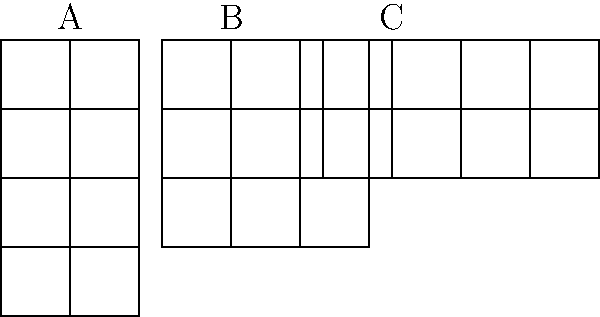Which dashboard layout (A, B, or C) would be most effective for displaying 8 different data quality metrics, considering the need for clear visualization and easy comparison? To determine the most effective layout for displaying 8 data quality metrics, we need to consider several factors:

1. Number of metrics: We need to display 8 metrics.

2. Layout options:
   A: 2 columns x 4 rows = 8 spaces
   B: 3 columns x 3 rows = 9 spaces
   C: 4 columns x 2 rows = 8 spaces

3. Comparison ease: 
   - Layout A allows easy vertical comparison within columns but harder horizontal comparison.
   - Layout B provides a balanced view but has an extra unused space.
   - Layout C offers the best horizontal comparison and maintains symmetry.

4. Screen real estate usage:
   - Layout C makes the most efficient use of horizontal space, which is typically more abundant on modern widescreen displays.

5. Data visualization principles:
   - Layout C adheres to the principle of proximity, grouping related metrics closer together horizontally.
   - It also follows the principle of alignment, creating a clean, organized appearance.

6. Cognitive load:
   - Layout C reduces eye movement by presenting metrics in a more compact horizontal arrangement.

Given these considerations, Layout C (4 columns x 2 rows) is the most effective for displaying 8 data quality metrics. It provides a balanced, symmetric layout that facilitates easy comparison, makes efficient use of screen space, and aligns with data visualization best practices.
Answer: Layout C 